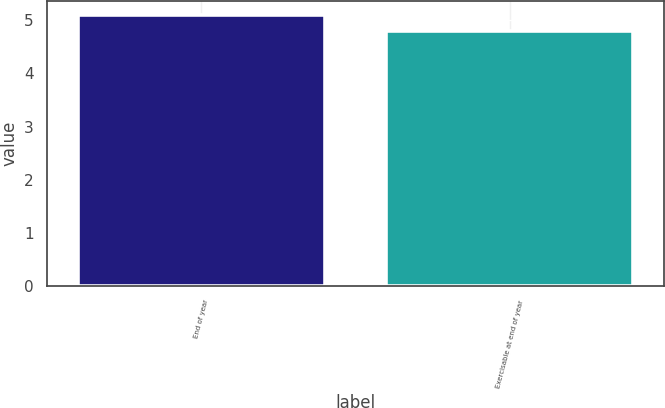Convert chart. <chart><loc_0><loc_0><loc_500><loc_500><bar_chart><fcel>End of year<fcel>Exercisable at end of year<nl><fcel>5.1<fcel>4.8<nl></chart> 